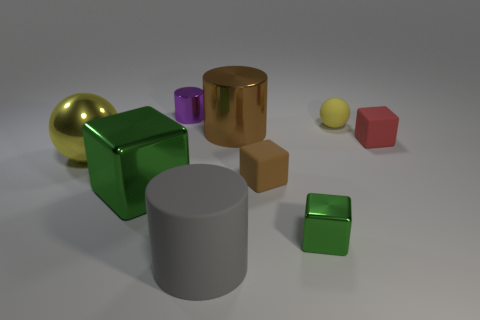Subtract all blue cubes. Subtract all purple cylinders. How many cubes are left? 4 Add 1 small objects. How many objects exist? 10 Subtract all blocks. How many objects are left? 5 Add 1 yellow rubber objects. How many yellow rubber objects exist? 2 Subtract 0 yellow cubes. How many objects are left? 9 Subtract all small yellow rubber objects. Subtract all shiny spheres. How many objects are left? 7 Add 9 tiny matte balls. How many tiny matte balls are left? 10 